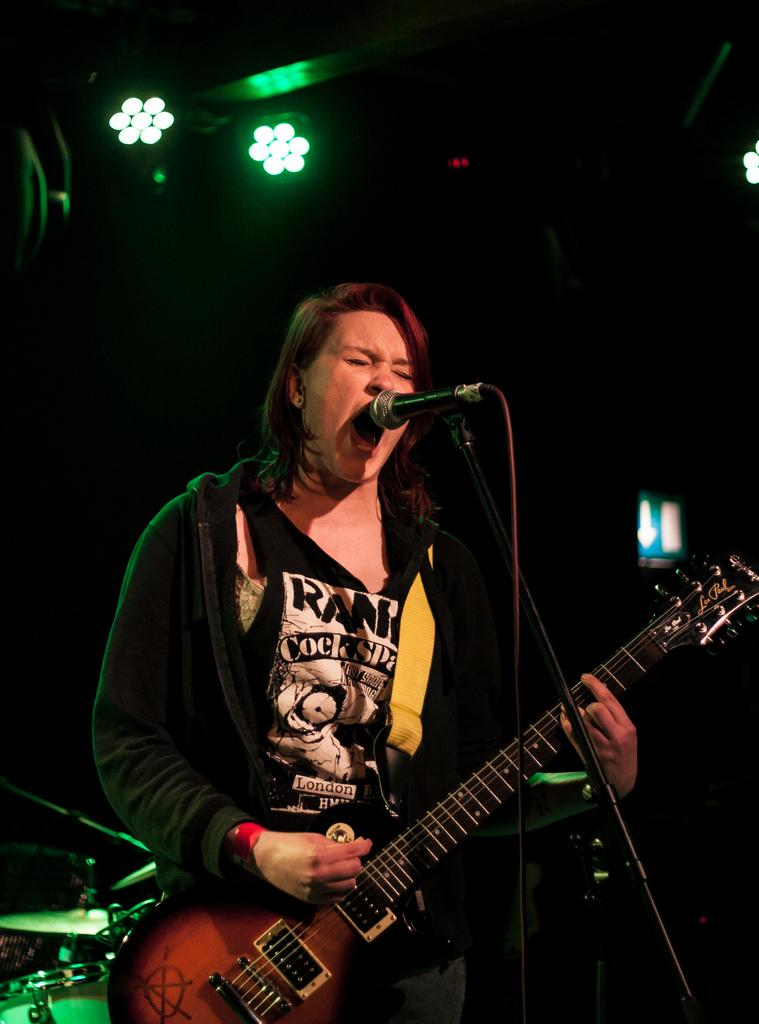Who is the main subject in the image? There is a woman in the image. What is the woman doing in the image? The woman is standing in front of a microphone and holding a guitar. What is the woman's mouth doing in the image? The woman's mouth is open. What can be seen behind the woman in the image? There are lights visible behind the woman. How does the woman's digestion process appear in the image? There is no indication of the woman's digestion process in the image. What type of cabbage is present in the image? There is no cabbage present in the image. 